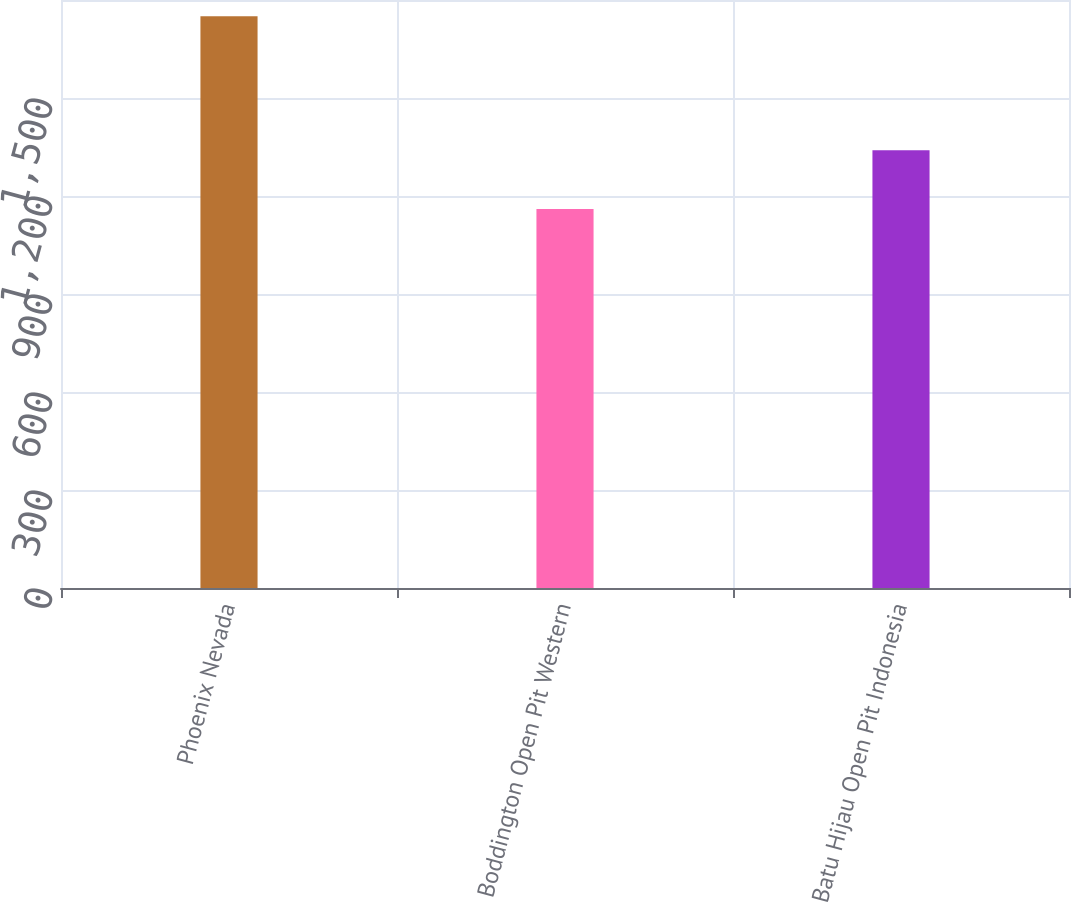Convert chart. <chart><loc_0><loc_0><loc_500><loc_500><bar_chart><fcel>Phoenix Nevada<fcel>Boddington Open Pit Western<fcel>Batu Hijau Open Pit Indonesia<nl><fcel>1750<fcel>1160<fcel>1340<nl></chart> 